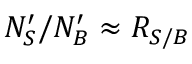Convert formula to latex. <formula><loc_0><loc_0><loc_500><loc_500>N _ { S } ^ { \prime } / N _ { B } ^ { \prime } \approx R _ { S / B }</formula> 